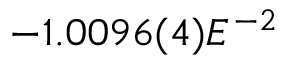Convert formula to latex. <formula><loc_0><loc_0><loc_500><loc_500>- 1 . 0 0 9 6 ( 4 ) E ^ { - 2 }</formula> 